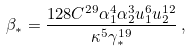<formula> <loc_0><loc_0><loc_500><loc_500>\beta _ { * } = \frac { 1 2 8 C ^ { 2 9 } \alpha _ { 1 } ^ { 4 } \alpha _ { 2 } ^ { 3 } u _ { 1 } ^ { 6 } u _ { 2 } ^ { 1 2 } } { \kappa ^ { 5 } \gamma _ { * } ^ { 1 9 } } \, ,</formula> 